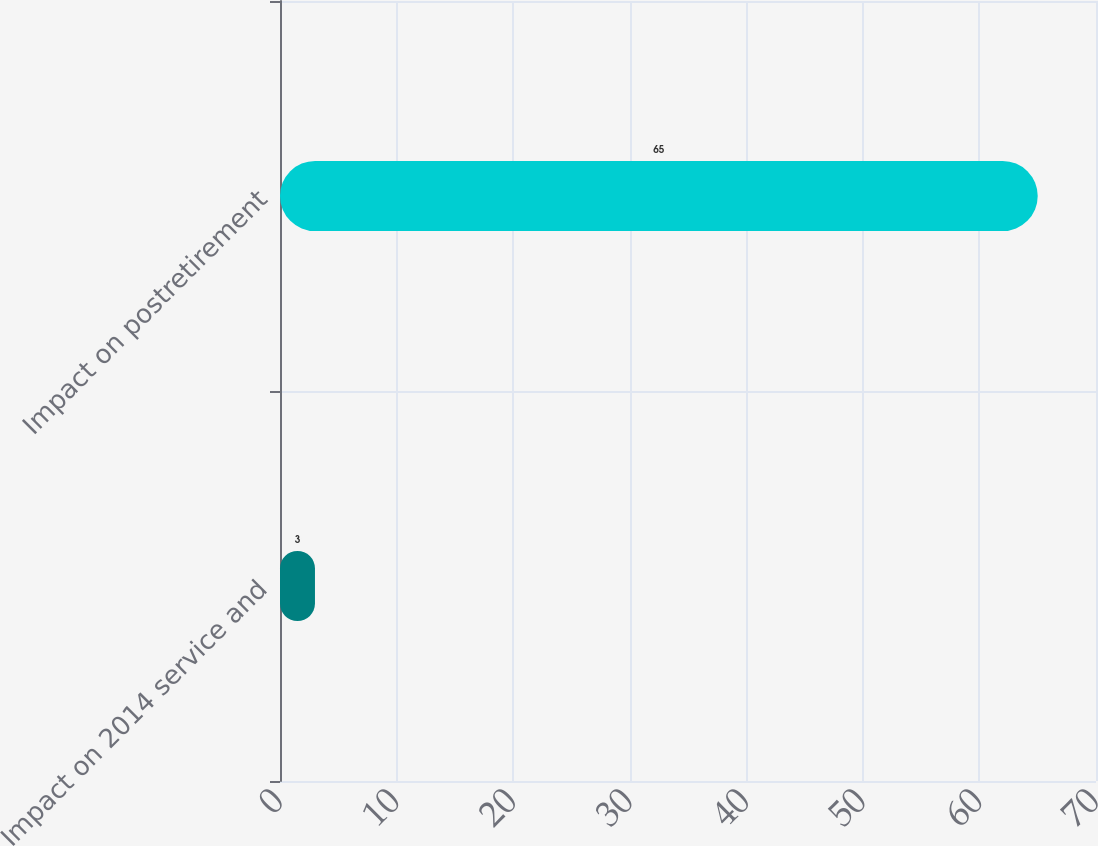Convert chart. <chart><loc_0><loc_0><loc_500><loc_500><bar_chart><fcel>Impact on 2014 service and<fcel>Impact on postretirement<nl><fcel>3<fcel>65<nl></chart> 